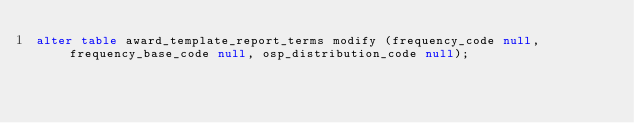<code> <loc_0><loc_0><loc_500><loc_500><_SQL_>alter table award_template_report_terms modify (frequency_code null, frequency_base_code null, osp_distribution_code null);</code> 